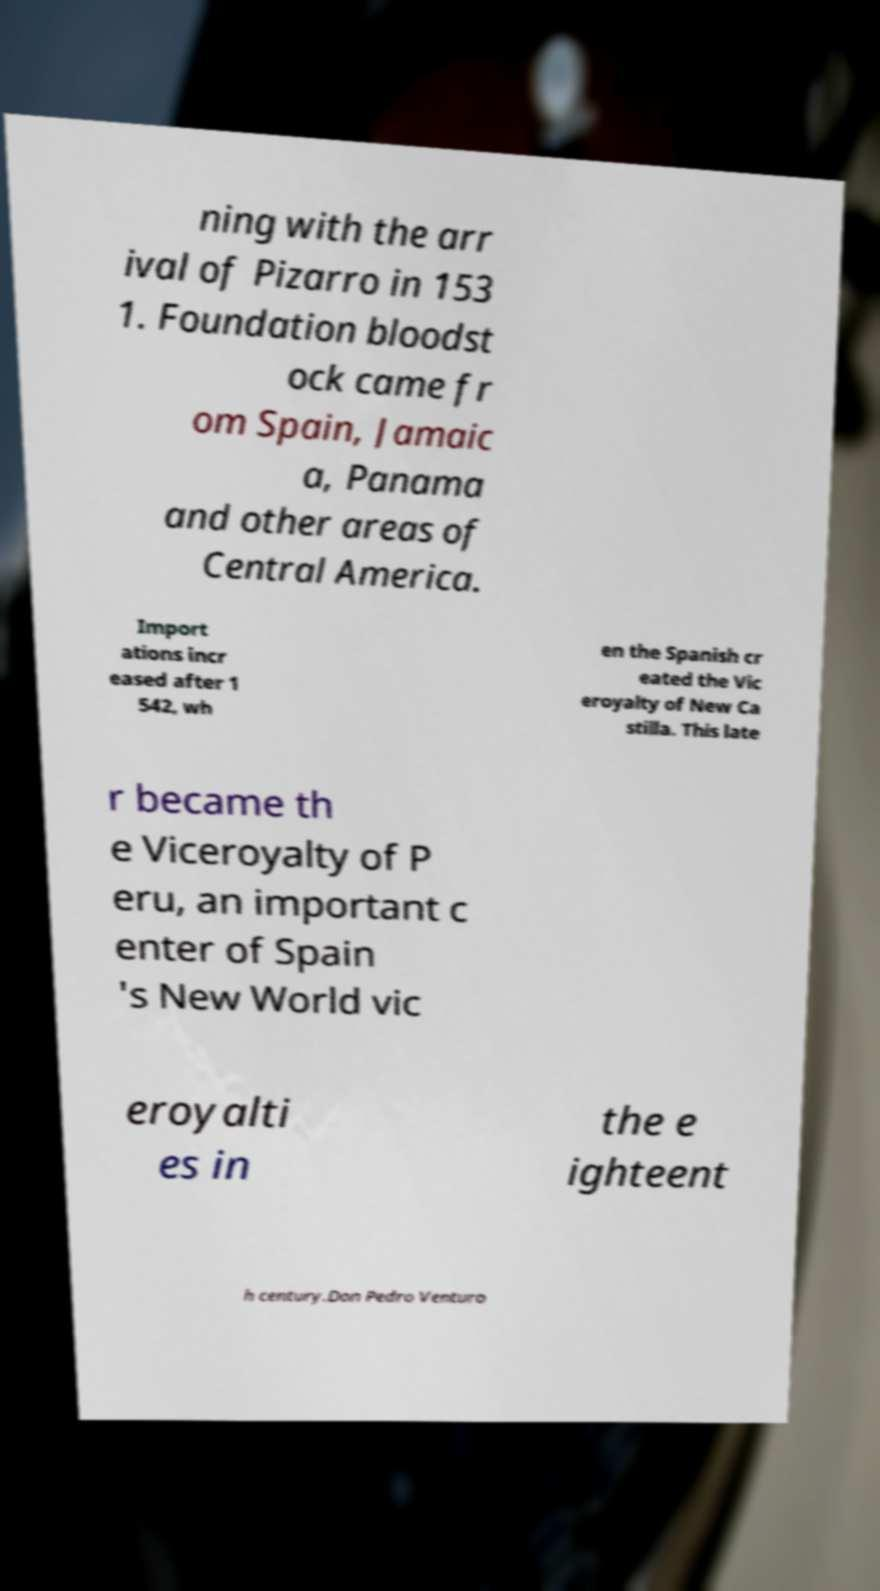Please read and relay the text visible in this image. What does it say? ning with the arr ival of Pizarro in 153 1. Foundation bloodst ock came fr om Spain, Jamaic a, Panama and other areas of Central America. Import ations incr eased after 1 542, wh en the Spanish cr eated the Vic eroyalty of New Ca stilla. This late r became th e Viceroyalty of P eru, an important c enter of Spain 's New World vic eroyalti es in the e ighteent h century.Don Pedro Venturo 